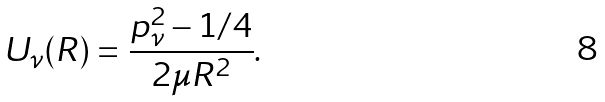Convert formula to latex. <formula><loc_0><loc_0><loc_500><loc_500>U _ { \nu } ( R ) = \frac { p _ { \nu } ^ { 2 } - 1 / 4 } { 2 \mu R ^ { 2 } } .</formula> 